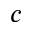Convert formula to latex. <formula><loc_0><loc_0><loc_500><loc_500>c</formula> 